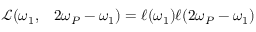Convert formula to latex. <formula><loc_0><loc_0><loc_500><loc_500>\begin{array} { r l } { \mathcal { L } ( \omega _ { 1 } , } & 2 \omega _ { P } - \omega _ { 1 } ) = \ell ( \omega _ { 1 } ) \ell ( 2 \omega _ { P } - \omega _ { 1 } ) } \end{array}</formula> 